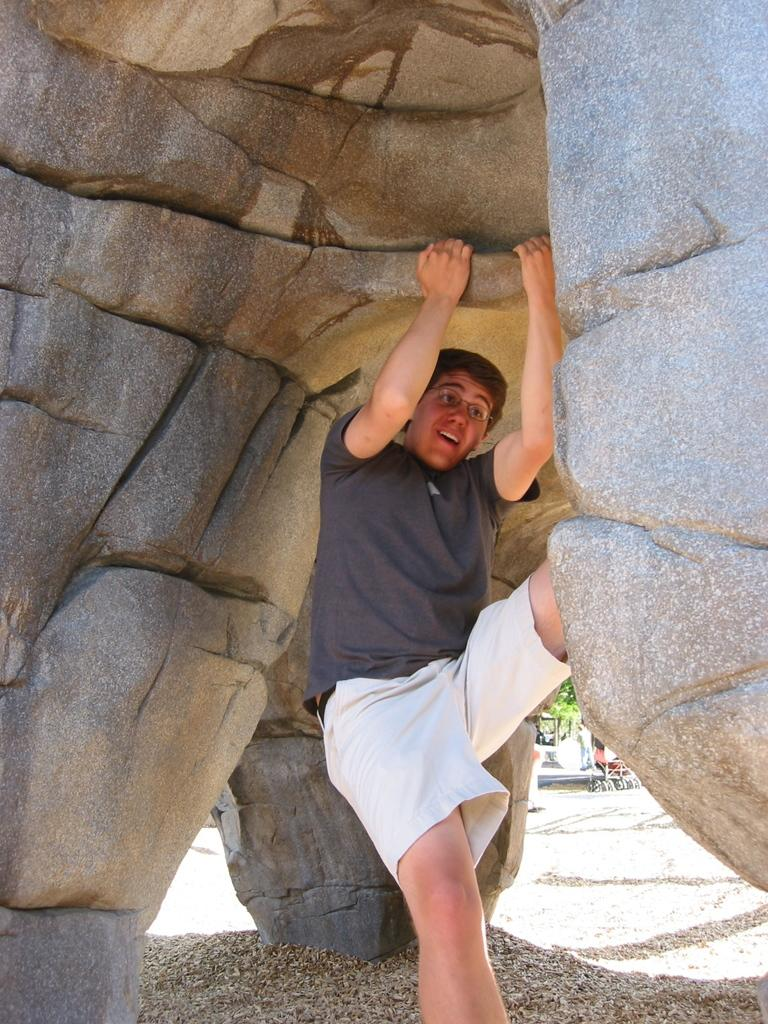What is the main subject of the image? There is a person in the image. How is the person positioned in the image? The person is hanging with the help of a rock. What type of sorting algorithm is the person using to climb the rock? The image does not show the person using any sorting algorithm to climb the rock. 